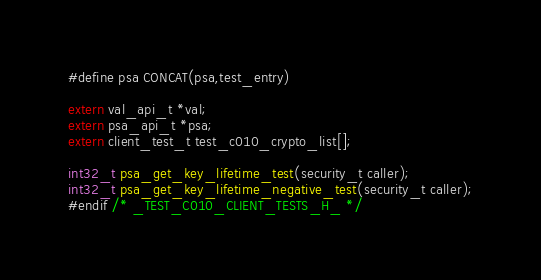Convert code to text. <code><loc_0><loc_0><loc_500><loc_500><_C_>#define psa CONCAT(psa,test_entry)

extern val_api_t *val;
extern psa_api_t *psa;
extern client_test_t test_c010_crypto_list[];

int32_t psa_get_key_lifetime_test(security_t caller);
int32_t psa_get_key_lifetime_negative_test(security_t caller);
#endif /* _TEST_C010_CLIENT_TESTS_H_ */
</code> 